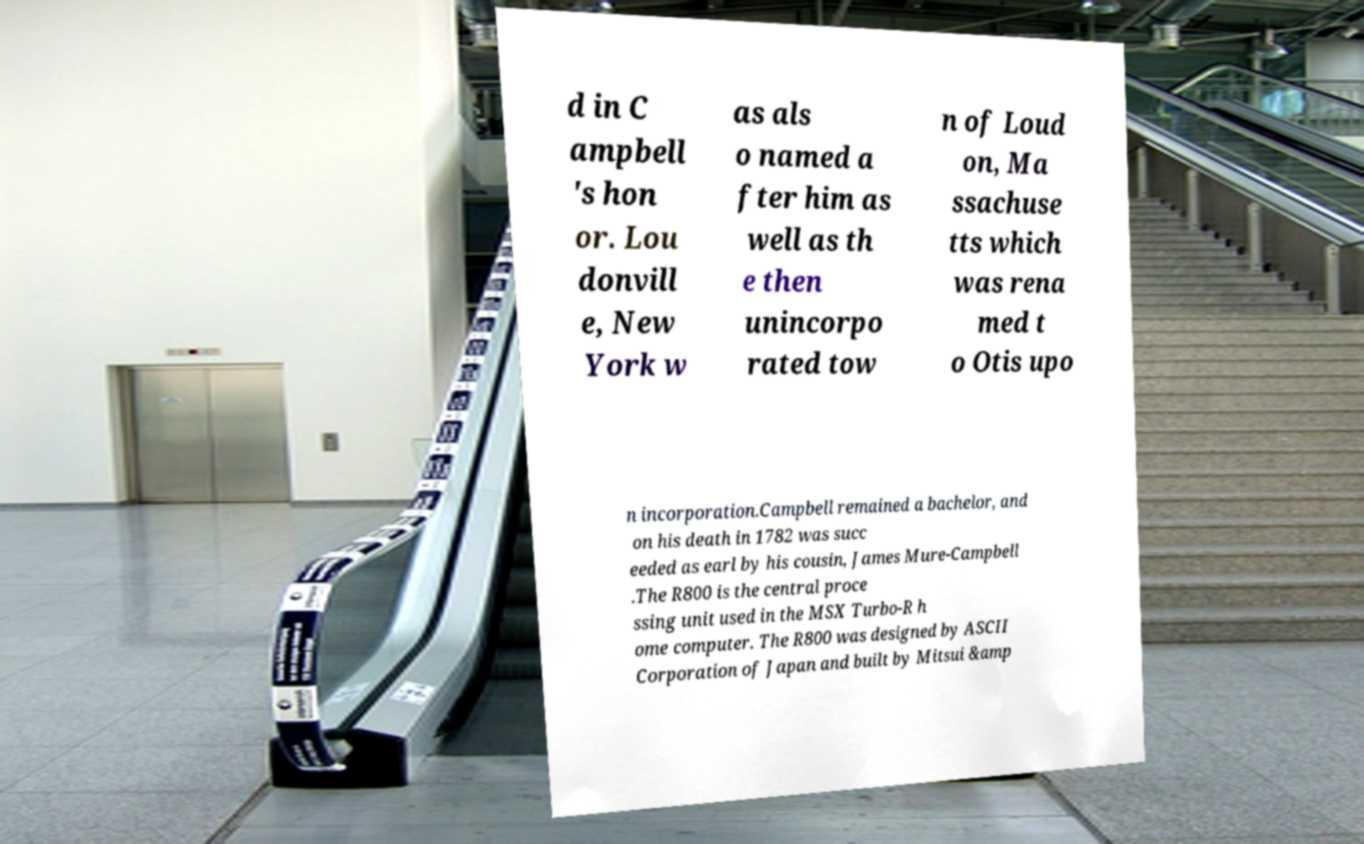Can you read and provide the text displayed in the image?This photo seems to have some interesting text. Can you extract and type it out for me? d in C ampbell 's hon or. Lou donvill e, New York w as als o named a fter him as well as th e then unincorpo rated tow n of Loud on, Ma ssachuse tts which was rena med t o Otis upo n incorporation.Campbell remained a bachelor, and on his death in 1782 was succ eeded as earl by his cousin, James Mure-Campbell .The R800 is the central proce ssing unit used in the MSX Turbo-R h ome computer. The R800 was designed by ASCII Corporation of Japan and built by Mitsui &amp 